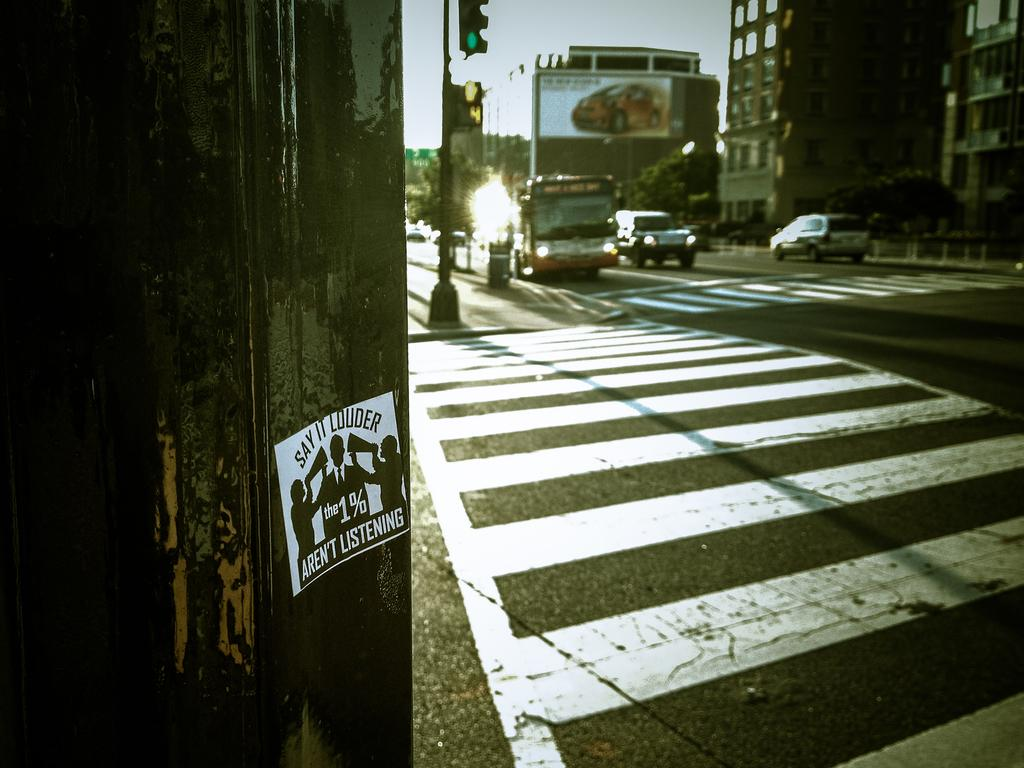What can be seen on the road in the image? There are vehicles on the road in the image. What is used to control the flow of traffic in the image? There is a traffic signal in the image. What type of structures can be seen in the background of the image? There are buildings visible in the background of the image. How is the sky described in the image? The sky is visible in the image, and it is described as white in color. Where is the camera placed in the image? There is no camera present in the image. What type of mint is growing on the sidewalk in the image? There is no mint or sidewalk present in the image. 